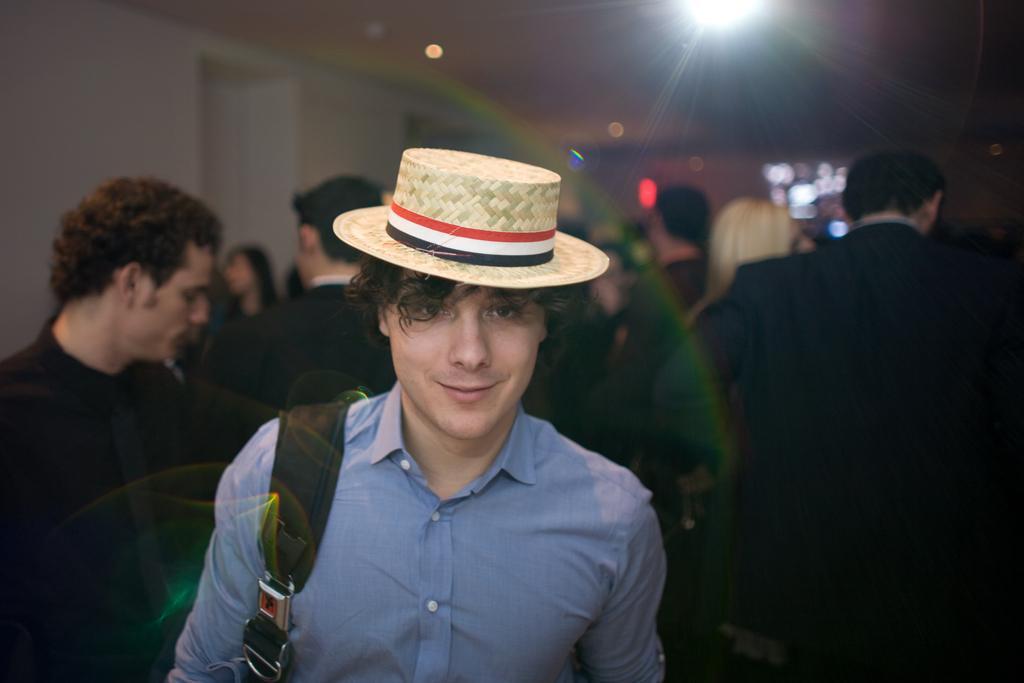Describe this image in one or two sentences. In the middle of the image a man is standing and smiling. Behind him few people are standing. At the top of the image there is wall and roof and lights. 